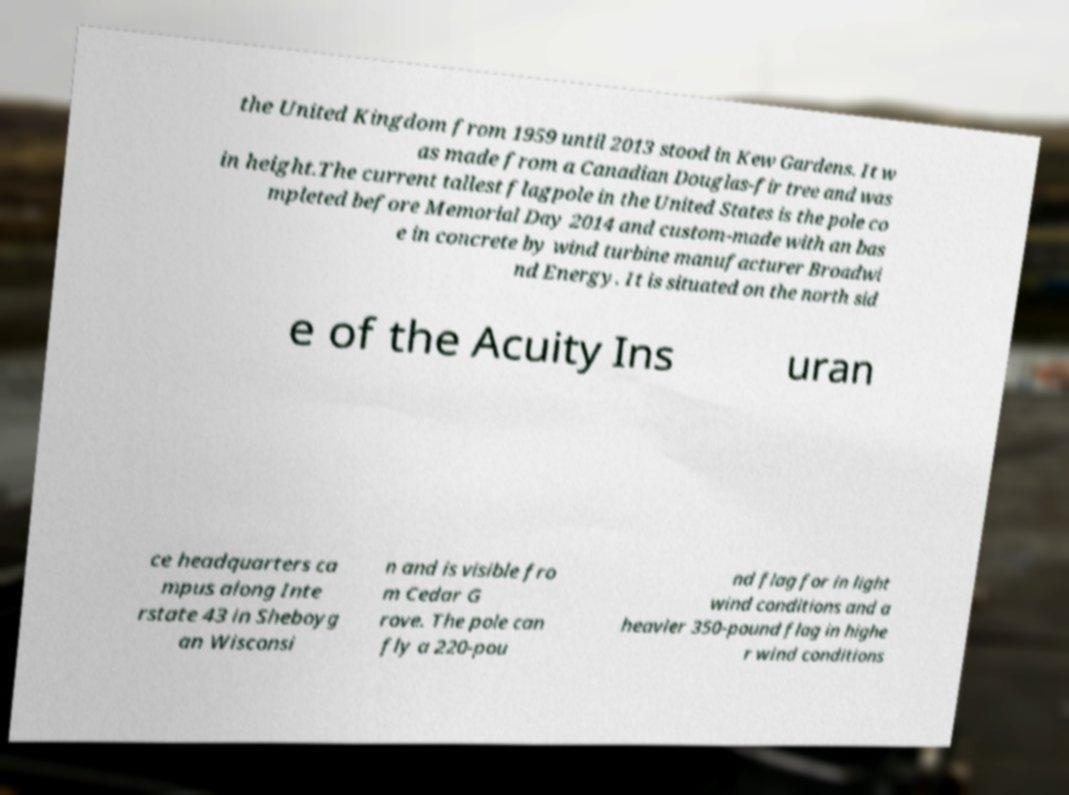Please read and relay the text visible in this image. What does it say? the United Kingdom from 1959 until 2013 stood in Kew Gardens. It w as made from a Canadian Douglas-fir tree and was in height.The current tallest flagpole in the United States is the pole co mpleted before Memorial Day 2014 and custom-made with an bas e in concrete by wind turbine manufacturer Broadwi nd Energy. It is situated on the north sid e of the Acuity Ins uran ce headquarters ca mpus along Inte rstate 43 in Sheboyg an Wisconsi n and is visible fro m Cedar G rove. The pole can fly a 220-pou nd flag for in light wind conditions and a heavier 350-pound flag in highe r wind conditions 